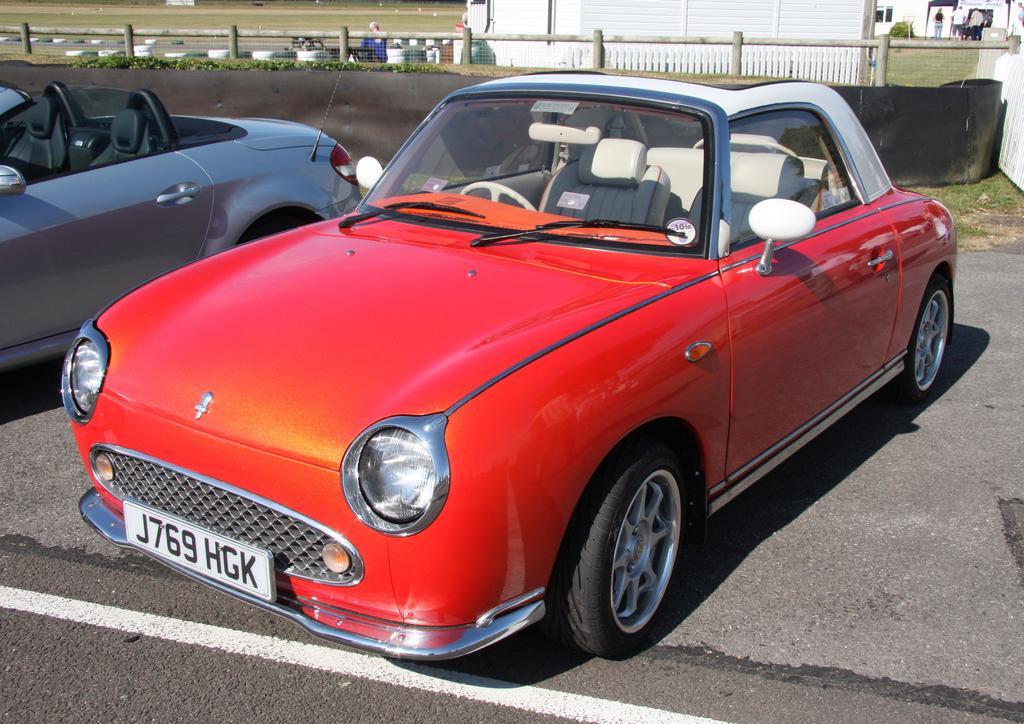In one or two sentences, can you explain what this image depicts? At the bottom of the picture, we see the road. In this picture, we see the cars in grey and red color are parked on the road. Behind that, we see a black color sheet, railing and a man in the blue shirt is standing. Beside him, we see a building in white color. In the right top, we see the people are standing. Beside them, we see the shrubs. In front of them, we see a building in white color. 